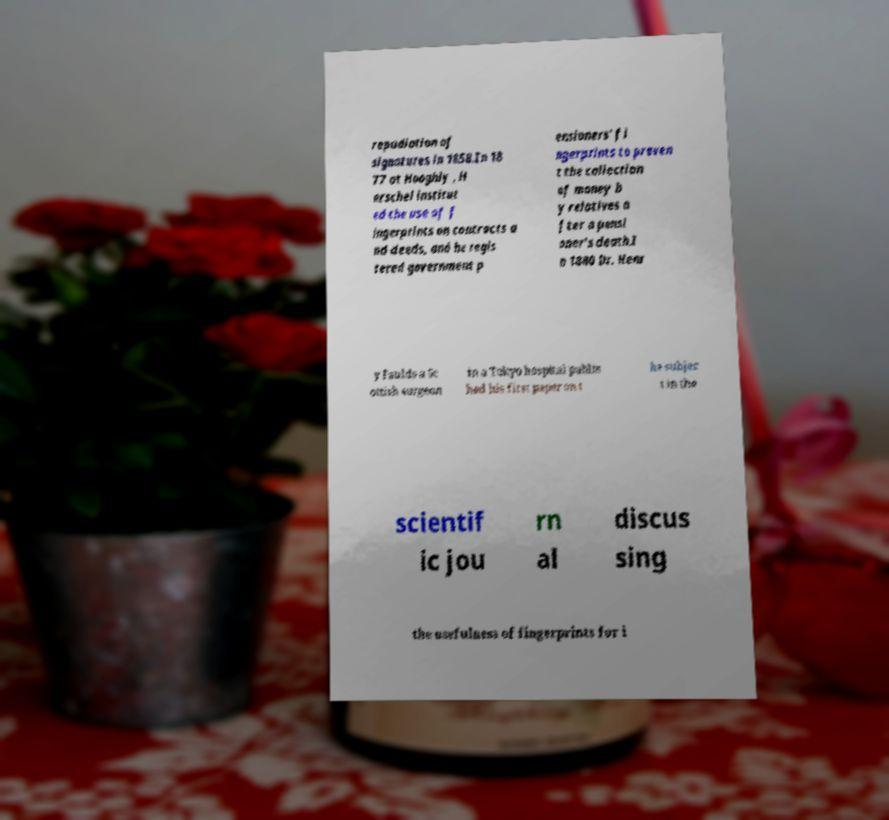Could you assist in decoding the text presented in this image and type it out clearly? repudiation of signatures in 1858.In 18 77 at Hooghly , H erschel institut ed the use of f ingerprints on contracts a nd deeds, and he regis tered government p ensioners' fi ngerprints to preven t the collection of money b y relatives a fter a pensi oner's death.I n 1880 Dr. Henr y Faulds a Sc ottish surgeon in a Tokyo hospital publis hed his first paper on t he subjec t in the scientif ic jou rn al discus sing the usefulness of fingerprints for i 